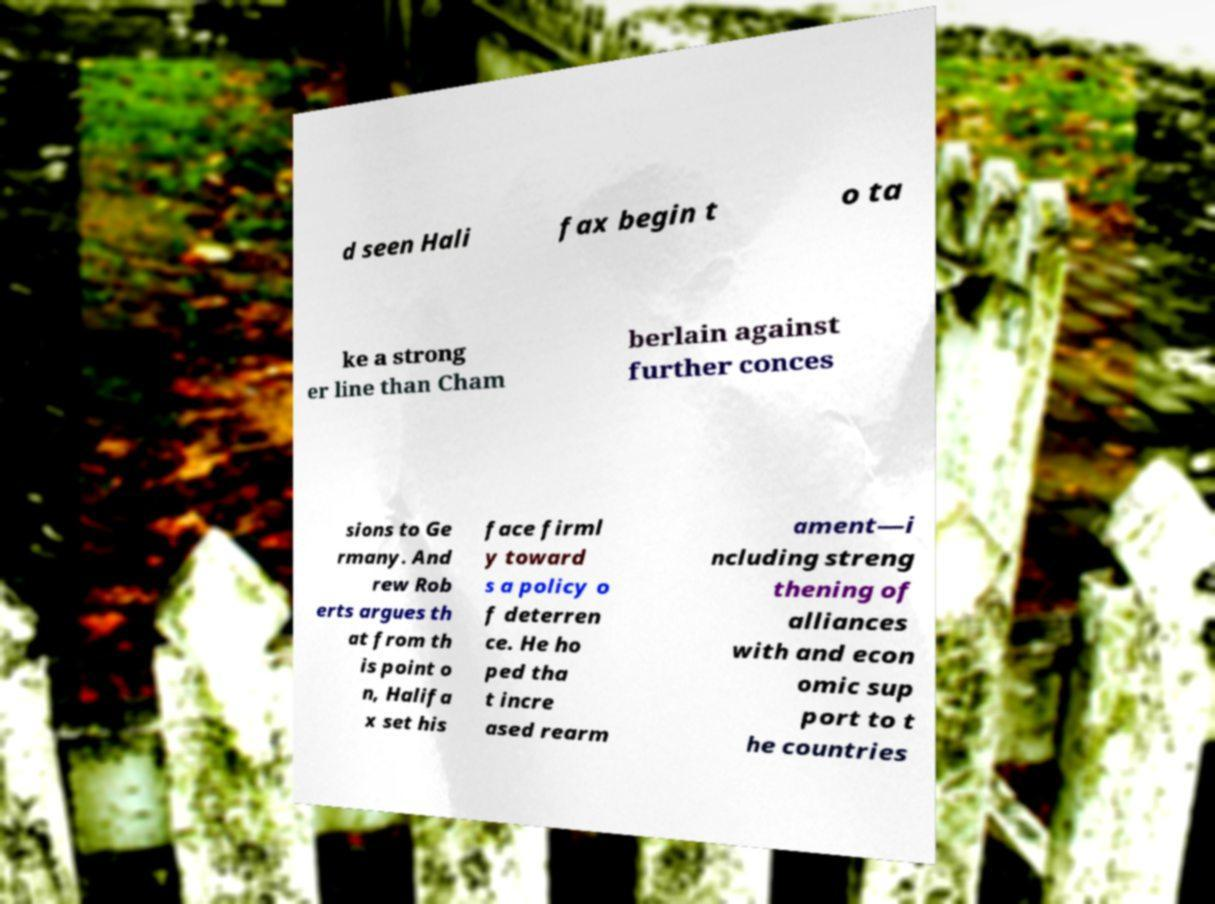What messages or text are displayed in this image? I need them in a readable, typed format. d seen Hali fax begin t o ta ke a strong er line than Cham berlain against further conces sions to Ge rmany. And rew Rob erts argues th at from th is point o n, Halifa x set his face firml y toward s a policy o f deterren ce. He ho ped tha t incre ased rearm ament—i ncluding streng thening of alliances with and econ omic sup port to t he countries 